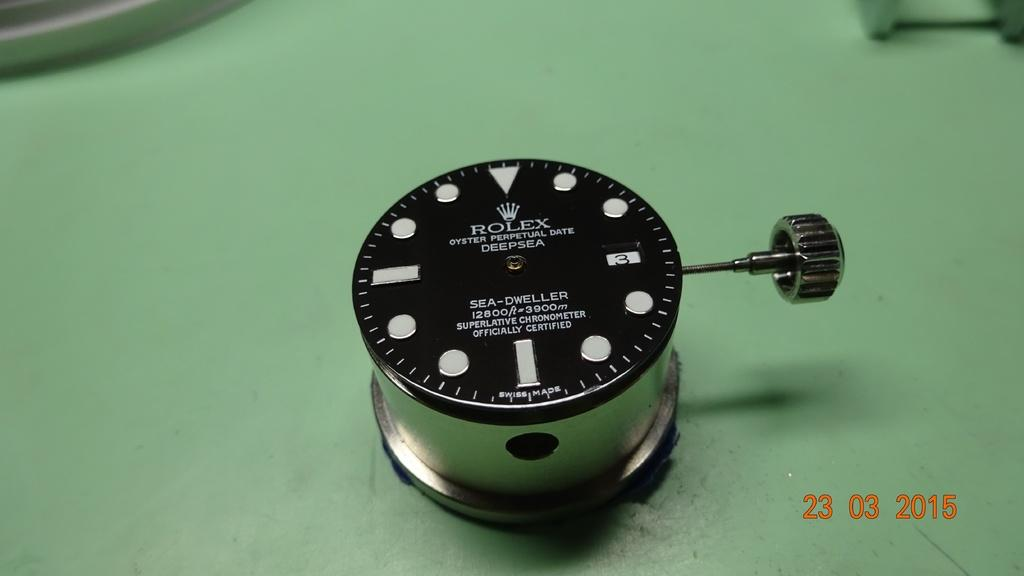<image>
Relay a brief, clear account of the picture shown. A Rolex Sea Dweller is sitting on a green table. 